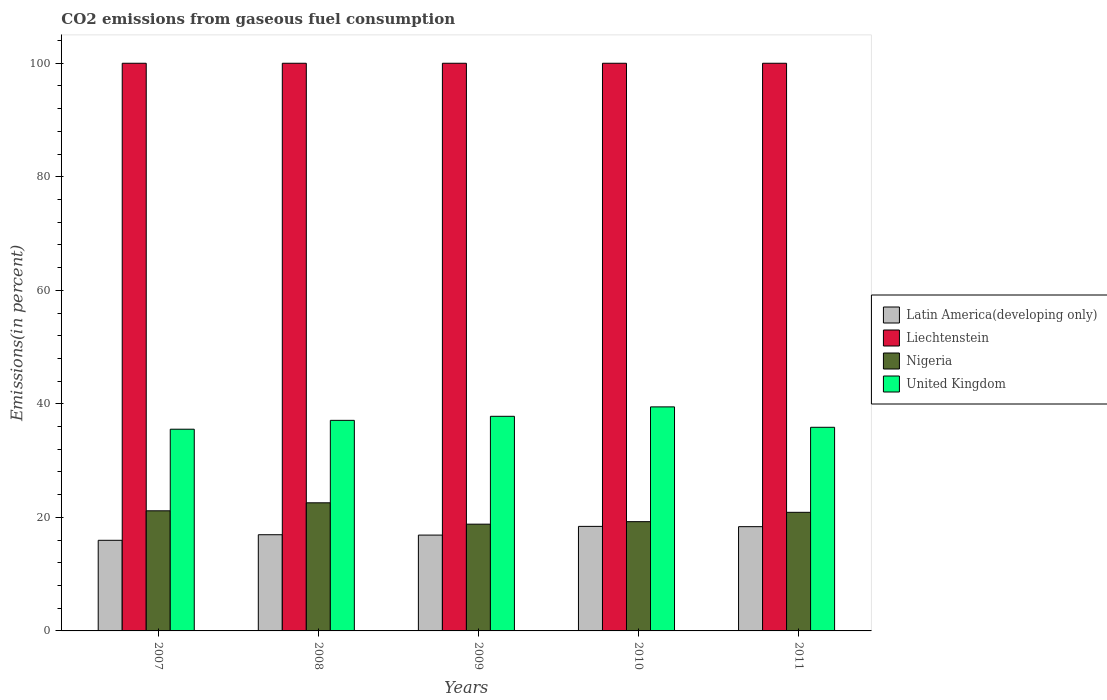Are the number of bars per tick equal to the number of legend labels?
Make the answer very short. Yes. How many bars are there on the 4th tick from the left?
Your answer should be very brief. 4. What is the label of the 3rd group of bars from the left?
Ensure brevity in your answer.  2009. In how many cases, is the number of bars for a given year not equal to the number of legend labels?
Your response must be concise. 0. Across all years, what is the maximum total CO2 emitted in Nigeria?
Ensure brevity in your answer.  22.57. Across all years, what is the minimum total CO2 emitted in Latin America(developing only)?
Your response must be concise. 15.96. In which year was the total CO2 emitted in United Kingdom minimum?
Your answer should be very brief. 2007. What is the total total CO2 emitted in Latin America(developing only) in the graph?
Provide a succinct answer. 86.57. What is the difference between the total CO2 emitted in Nigeria in 2007 and that in 2010?
Your response must be concise. 1.91. What is the difference between the total CO2 emitted in Latin America(developing only) in 2011 and the total CO2 emitted in Liechtenstein in 2009?
Keep it short and to the point. -81.64. What is the average total CO2 emitted in Latin America(developing only) per year?
Offer a terse response. 17.31. In the year 2008, what is the difference between the total CO2 emitted in Nigeria and total CO2 emitted in Latin America(developing only)?
Provide a short and direct response. 5.62. Is the difference between the total CO2 emitted in Nigeria in 2009 and 2011 greater than the difference between the total CO2 emitted in Latin America(developing only) in 2009 and 2011?
Give a very brief answer. No. What is the difference between the highest and the second highest total CO2 emitted in Latin America(developing only)?
Provide a short and direct response. 0.05. What is the difference between the highest and the lowest total CO2 emitted in Liechtenstein?
Keep it short and to the point. 0. In how many years, is the total CO2 emitted in United Kingdom greater than the average total CO2 emitted in United Kingdom taken over all years?
Ensure brevity in your answer.  2. Is the sum of the total CO2 emitted in United Kingdom in 2008 and 2011 greater than the maximum total CO2 emitted in Liechtenstein across all years?
Ensure brevity in your answer.  No. What does the 3rd bar from the left in 2009 represents?
Offer a very short reply. Nigeria. What does the 3rd bar from the right in 2011 represents?
Offer a very short reply. Liechtenstein. Is it the case that in every year, the sum of the total CO2 emitted in United Kingdom and total CO2 emitted in Nigeria is greater than the total CO2 emitted in Latin America(developing only)?
Your answer should be very brief. Yes. Are all the bars in the graph horizontal?
Offer a very short reply. No. Are the values on the major ticks of Y-axis written in scientific E-notation?
Your response must be concise. No. Does the graph contain grids?
Your response must be concise. No. How are the legend labels stacked?
Your response must be concise. Vertical. What is the title of the graph?
Your response must be concise. CO2 emissions from gaseous fuel consumption. What is the label or title of the Y-axis?
Keep it short and to the point. Emissions(in percent). What is the Emissions(in percent) in Latin America(developing only) in 2007?
Your answer should be very brief. 15.96. What is the Emissions(in percent) in Liechtenstein in 2007?
Make the answer very short. 100. What is the Emissions(in percent) in Nigeria in 2007?
Your answer should be compact. 21.16. What is the Emissions(in percent) of United Kingdom in 2007?
Keep it short and to the point. 35.53. What is the Emissions(in percent) of Latin America(developing only) in 2008?
Give a very brief answer. 16.94. What is the Emissions(in percent) of Nigeria in 2008?
Offer a very short reply. 22.57. What is the Emissions(in percent) of United Kingdom in 2008?
Your answer should be compact. 37.1. What is the Emissions(in percent) of Latin America(developing only) in 2009?
Ensure brevity in your answer.  16.88. What is the Emissions(in percent) of Nigeria in 2009?
Provide a short and direct response. 18.81. What is the Emissions(in percent) of United Kingdom in 2009?
Offer a very short reply. 37.81. What is the Emissions(in percent) of Latin America(developing only) in 2010?
Provide a short and direct response. 18.42. What is the Emissions(in percent) of Nigeria in 2010?
Your answer should be very brief. 19.25. What is the Emissions(in percent) of United Kingdom in 2010?
Your response must be concise. 39.47. What is the Emissions(in percent) in Latin America(developing only) in 2011?
Make the answer very short. 18.36. What is the Emissions(in percent) in Nigeria in 2011?
Offer a very short reply. 20.89. What is the Emissions(in percent) in United Kingdom in 2011?
Your answer should be very brief. 35.87. Across all years, what is the maximum Emissions(in percent) in Latin America(developing only)?
Your response must be concise. 18.42. Across all years, what is the maximum Emissions(in percent) in Liechtenstein?
Keep it short and to the point. 100. Across all years, what is the maximum Emissions(in percent) of Nigeria?
Your answer should be very brief. 22.57. Across all years, what is the maximum Emissions(in percent) in United Kingdom?
Give a very brief answer. 39.47. Across all years, what is the minimum Emissions(in percent) in Latin America(developing only)?
Ensure brevity in your answer.  15.96. Across all years, what is the minimum Emissions(in percent) in Liechtenstein?
Give a very brief answer. 100. Across all years, what is the minimum Emissions(in percent) of Nigeria?
Ensure brevity in your answer.  18.81. Across all years, what is the minimum Emissions(in percent) of United Kingdom?
Offer a terse response. 35.53. What is the total Emissions(in percent) of Latin America(developing only) in the graph?
Keep it short and to the point. 86.57. What is the total Emissions(in percent) of Nigeria in the graph?
Give a very brief answer. 102.67. What is the total Emissions(in percent) of United Kingdom in the graph?
Provide a short and direct response. 185.77. What is the difference between the Emissions(in percent) of Latin America(developing only) in 2007 and that in 2008?
Your answer should be very brief. -0.98. What is the difference between the Emissions(in percent) of Nigeria in 2007 and that in 2008?
Your answer should be compact. -1.41. What is the difference between the Emissions(in percent) in United Kingdom in 2007 and that in 2008?
Your answer should be very brief. -1.56. What is the difference between the Emissions(in percent) of Latin America(developing only) in 2007 and that in 2009?
Keep it short and to the point. -0.92. What is the difference between the Emissions(in percent) of Liechtenstein in 2007 and that in 2009?
Provide a short and direct response. 0. What is the difference between the Emissions(in percent) in Nigeria in 2007 and that in 2009?
Make the answer very short. 2.35. What is the difference between the Emissions(in percent) in United Kingdom in 2007 and that in 2009?
Provide a short and direct response. -2.28. What is the difference between the Emissions(in percent) in Latin America(developing only) in 2007 and that in 2010?
Offer a terse response. -2.45. What is the difference between the Emissions(in percent) in Nigeria in 2007 and that in 2010?
Ensure brevity in your answer.  1.91. What is the difference between the Emissions(in percent) of United Kingdom in 2007 and that in 2010?
Make the answer very short. -3.93. What is the difference between the Emissions(in percent) of Latin America(developing only) in 2007 and that in 2011?
Keep it short and to the point. -2.4. What is the difference between the Emissions(in percent) in Liechtenstein in 2007 and that in 2011?
Your response must be concise. 0. What is the difference between the Emissions(in percent) in Nigeria in 2007 and that in 2011?
Your answer should be very brief. 0.27. What is the difference between the Emissions(in percent) of United Kingdom in 2007 and that in 2011?
Make the answer very short. -0.34. What is the difference between the Emissions(in percent) of Latin America(developing only) in 2008 and that in 2009?
Ensure brevity in your answer.  0.06. What is the difference between the Emissions(in percent) in Liechtenstein in 2008 and that in 2009?
Your answer should be compact. 0. What is the difference between the Emissions(in percent) of Nigeria in 2008 and that in 2009?
Ensure brevity in your answer.  3.76. What is the difference between the Emissions(in percent) in United Kingdom in 2008 and that in 2009?
Give a very brief answer. -0.71. What is the difference between the Emissions(in percent) of Latin America(developing only) in 2008 and that in 2010?
Give a very brief answer. -1.47. What is the difference between the Emissions(in percent) of Liechtenstein in 2008 and that in 2010?
Your answer should be compact. 0. What is the difference between the Emissions(in percent) in Nigeria in 2008 and that in 2010?
Offer a terse response. 3.32. What is the difference between the Emissions(in percent) of United Kingdom in 2008 and that in 2010?
Provide a short and direct response. -2.37. What is the difference between the Emissions(in percent) of Latin America(developing only) in 2008 and that in 2011?
Ensure brevity in your answer.  -1.42. What is the difference between the Emissions(in percent) in Liechtenstein in 2008 and that in 2011?
Your answer should be compact. 0. What is the difference between the Emissions(in percent) of Nigeria in 2008 and that in 2011?
Your answer should be very brief. 1.68. What is the difference between the Emissions(in percent) in United Kingdom in 2008 and that in 2011?
Provide a short and direct response. 1.22. What is the difference between the Emissions(in percent) of Latin America(developing only) in 2009 and that in 2010?
Make the answer very short. -1.53. What is the difference between the Emissions(in percent) in Nigeria in 2009 and that in 2010?
Offer a very short reply. -0.44. What is the difference between the Emissions(in percent) in United Kingdom in 2009 and that in 2010?
Provide a short and direct response. -1.66. What is the difference between the Emissions(in percent) in Latin America(developing only) in 2009 and that in 2011?
Your response must be concise. -1.48. What is the difference between the Emissions(in percent) of Liechtenstein in 2009 and that in 2011?
Give a very brief answer. 0. What is the difference between the Emissions(in percent) of Nigeria in 2009 and that in 2011?
Make the answer very short. -2.08. What is the difference between the Emissions(in percent) of United Kingdom in 2009 and that in 2011?
Offer a terse response. 1.94. What is the difference between the Emissions(in percent) of Latin America(developing only) in 2010 and that in 2011?
Ensure brevity in your answer.  0.05. What is the difference between the Emissions(in percent) of Liechtenstein in 2010 and that in 2011?
Offer a very short reply. 0. What is the difference between the Emissions(in percent) of Nigeria in 2010 and that in 2011?
Your answer should be compact. -1.64. What is the difference between the Emissions(in percent) in United Kingdom in 2010 and that in 2011?
Your answer should be very brief. 3.6. What is the difference between the Emissions(in percent) of Latin America(developing only) in 2007 and the Emissions(in percent) of Liechtenstein in 2008?
Offer a very short reply. -84.04. What is the difference between the Emissions(in percent) in Latin America(developing only) in 2007 and the Emissions(in percent) in Nigeria in 2008?
Give a very brief answer. -6.6. What is the difference between the Emissions(in percent) in Latin America(developing only) in 2007 and the Emissions(in percent) in United Kingdom in 2008?
Make the answer very short. -21.13. What is the difference between the Emissions(in percent) of Liechtenstein in 2007 and the Emissions(in percent) of Nigeria in 2008?
Keep it short and to the point. 77.43. What is the difference between the Emissions(in percent) in Liechtenstein in 2007 and the Emissions(in percent) in United Kingdom in 2008?
Offer a terse response. 62.9. What is the difference between the Emissions(in percent) in Nigeria in 2007 and the Emissions(in percent) in United Kingdom in 2008?
Give a very brief answer. -15.94. What is the difference between the Emissions(in percent) of Latin America(developing only) in 2007 and the Emissions(in percent) of Liechtenstein in 2009?
Your answer should be very brief. -84.04. What is the difference between the Emissions(in percent) of Latin America(developing only) in 2007 and the Emissions(in percent) of Nigeria in 2009?
Give a very brief answer. -2.84. What is the difference between the Emissions(in percent) of Latin America(developing only) in 2007 and the Emissions(in percent) of United Kingdom in 2009?
Offer a terse response. -21.84. What is the difference between the Emissions(in percent) of Liechtenstein in 2007 and the Emissions(in percent) of Nigeria in 2009?
Make the answer very short. 81.19. What is the difference between the Emissions(in percent) of Liechtenstein in 2007 and the Emissions(in percent) of United Kingdom in 2009?
Your response must be concise. 62.19. What is the difference between the Emissions(in percent) in Nigeria in 2007 and the Emissions(in percent) in United Kingdom in 2009?
Offer a very short reply. -16.65. What is the difference between the Emissions(in percent) in Latin America(developing only) in 2007 and the Emissions(in percent) in Liechtenstein in 2010?
Offer a very short reply. -84.04. What is the difference between the Emissions(in percent) in Latin America(developing only) in 2007 and the Emissions(in percent) in Nigeria in 2010?
Keep it short and to the point. -3.28. What is the difference between the Emissions(in percent) in Latin America(developing only) in 2007 and the Emissions(in percent) in United Kingdom in 2010?
Offer a terse response. -23.5. What is the difference between the Emissions(in percent) of Liechtenstein in 2007 and the Emissions(in percent) of Nigeria in 2010?
Provide a succinct answer. 80.75. What is the difference between the Emissions(in percent) in Liechtenstein in 2007 and the Emissions(in percent) in United Kingdom in 2010?
Keep it short and to the point. 60.53. What is the difference between the Emissions(in percent) of Nigeria in 2007 and the Emissions(in percent) of United Kingdom in 2010?
Offer a very short reply. -18.31. What is the difference between the Emissions(in percent) of Latin America(developing only) in 2007 and the Emissions(in percent) of Liechtenstein in 2011?
Provide a succinct answer. -84.04. What is the difference between the Emissions(in percent) of Latin America(developing only) in 2007 and the Emissions(in percent) of Nigeria in 2011?
Give a very brief answer. -4.93. What is the difference between the Emissions(in percent) in Latin America(developing only) in 2007 and the Emissions(in percent) in United Kingdom in 2011?
Make the answer very short. -19.91. What is the difference between the Emissions(in percent) of Liechtenstein in 2007 and the Emissions(in percent) of Nigeria in 2011?
Offer a terse response. 79.11. What is the difference between the Emissions(in percent) in Liechtenstein in 2007 and the Emissions(in percent) in United Kingdom in 2011?
Your response must be concise. 64.13. What is the difference between the Emissions(in percent) in Nigeria in 2007 and the Emissions(in percent) in United Kingdom in 2011?
Your answer should be compact. -14.71. What is the difference between the Emissions(in percent) in Latin America(developing only) in 2008 and the Emissions(in percent) in Liechtenstein in 2009?
Provide a short and direct response. -83.06. What is the difference between the Emissions(in percent) of Latin America(developing only) in 2008 and the Emissions(in percent) of Nigeria in 2009?
Your answer should be very brief. -1.86. What is the difference between the Emissions(in percent) of Latin America(developing only) in 2008 and the Emissions(in percent) of United Kingdom in 2009?
Offer a terse response. -20.86. What is the difference between the Emissions(in percent) of Liechtenstein in 2008 and the Emissions(in percent) of Nigeria in 2009?
Your answer should be very brief. 81.19. What is the difference between the Emissions(in percent) of Liechtenstein in 2008 and the Emissions(in percent) of United Kingdom in 2009?
Make the answer very short. 62.19. What is the difference between the Emissions(in percent) of Nigeria in 2008 and the Emissions(in percent) of United Kingdom in 2009?
Make the answer very short. -15.24. What is the difference between the Emissions(in percent) of Latin America(developing only) in 2008 and the Emissions(in percent) of Liechtenstein in 2010?
Your answer should be very brief. -83.06. What is the difference between the Emissions(in percent) in Latin America(developing only) in 2008 and the Emissions(in percent) in Nigeria in 2010?
Keep it short and to the point. -2.3. What is the difference between the Emissions(in percent) of Latin America(developing only) in 2008 and the Emissions(in percent) of United Kingdom in 2010?
Provide a succinct answer. -22.52. What is the difference between the Emissions(in percent) in Liechtenstein in 2008 and the Emissions(in percent) in Nigeria in 2010?
Your response must be concise. 80.75. What is the difference between the Emissions(in percent) of Liechtenstein in 2008 and the Emissions(in percent) of United Kingdom in 2010?
Offer a very short reply. 60.53. What is the difference between the Emissions(in percent) in Nigeria in 2008 and the Emissions(in percent) in United Kingdom in 2010?
Give a very brief answer. -16.9. What is the difference between the Emissions(in percent) of Latin America(developing only) in 2008 and the Emissions(in percent) of Liechtenstein in 2011?
Your answer should be compact. -83.06. What is the difference between the Emissions(in percent) of Latin America(developing only) in 2008 and the Emissions(in percent) of Nigeria in 2011?
Your answer should be very brief. -3.95. What is the difference between the Emissions(in percent) in Latin America(developing only) in 2008 and the Emissions(in percent) in United Kingdom in 2011?
Your response must be concise. -18.93. What is the difference between the Emissions(in percent) in Liechtenstein in 2008 and the Emissions(in percent) in Nigeria in 2011?
Your answer should be compact. 79.11. What is the difference between the Emissions(in percent) of Liechtenstein in 2008 and the Emissions(in percent) of United Kingdom in 2011?
Give a very brief answer. 64.13. What is the difference between the Emissions(in percent) in Nigeria in 2008 and the Emissions(in percent) in United Kingdom in 2011?
Provide a short and direct response. -13.3. What is the difference between the Emissions(in percent) in Latin America(developing only) in 2009 and the Emissions(in percent) in Liechtenstein in 2010?
Keep it short and to the point. -83.12. What is the difference between the Emissions(in percent) in Latin America(developing only) in 2009 and the Emissions(in percent) in Nigeria in 2010?
Your answer should be very brief. -2.36. What is the difference between the Emissions(in percent) of Latin America(developing only) in 2009 and the Emissions(in percent) of United Kingdom in 2010?
Your answer should be very brief. -22.58. What is the difference between the Emissions(in percent) of Liechtenstein in 2009 and the Emissions(in percent) of Nigeria in 2010?
Give a very brief answer. 80.75. What is the difference between the Emissions(in percent) in Liechtenstein in 2009 and the Emissions(in percent) in United Kingdom in 2010?
Give a very brief answer. 60.53. What is the difference between the Emissions(in percent) of Nigeria in 2009 and the Emissions(in percent) of United Kingdom in 2010?
Provide a succinct answer. -20.66. What is the difference between the Emissions(in percent) of Latin America(developing only) in 2009 and the Emissions(in percent) of Liechtenstein in 2011?
Provide a short and direct response. -83.12. What is the difference between the Emissions(in percent) in Latin America(developing only) in 2009 and the Emissions(in percent) in Nigeria in 2011?
Offer a very short reply. -4.01. What is the difference between the Emissions(in percent) in Latin America(developing only) in 2009 and the Emissions(in percent) in United Kingdom in 2011?
Provide a succinct answer. -18.99. What is the difference between the Emissions(in percent) of Liechtenstein in 2009 and the Emissions(in percent) of Nigeria in 2011?
Ensure brevity in your answer.  79.11. What is the difference between the Emissions(in percent) in Liechtenstein in 2009 and the Emissions(in percent) in United Kingdom in 2011?
Keep it short and to the point. 64.13. What is the difference between the Emissions(in percent) of Nigeria in 2009 and the Emissions(in percent) of United Kingdom in 2011?
Provide a short and direct response. -17.06. What is the difference between the Emissions(in percent) of Latin America(developing only) in 2010 and the Emissions(in percent) of Liechtenstein in 2011?
Provide a succinct answer. -81.58. What is the difference between the Emissions(in percent) in Latin America(developing only) in 2010 and the Emissions(in percent) in Nigeria in 2011?
Keep it short and to the point. -2.48. What is the difference between the Emissions(in percent) in Latin America(developing only) in 2010 and the Emissions(in percent) in United Kingdom in 2011?
Your response must be concise. -17.46. What is the difference between the Emissions(in percent) in Liechtenstein in 2010 and the Emissions(in percent) in Nigeria in 2011?
Provide a short and direct response. 79.11. What is the difference between the Emissions(in percent) in Liechtenstein in 2010 and the Emissions(in percent) in United Kingdom in 2011?
Ensure brevity in your answer.  64.13. What is the difference between the Emissions(in percent) of Nigeria in 2010 and the Emissions(in percent) of United Kingdom in 2011?
Your answer should be very brief. -16.62. What is the average Emissions(in percent) in Latin America(developing only) per year?
Offer a very short reply. 17.31. What is the average Emissions(in percent) in Nigeria per year?
Keep it short and to the point. 20.53. What is the average Emissions(in percent) of United Kingdom per year?
Offer a terse response. 37.15. In the year 2007, what is the difference between the Emissions(in percent) of Latin America(developing only) and Emissions(in percent) of Liechtenstein?
Your answer should be very brief. -84.04. In the year 2007, what is the difference between the Emissions(in percent) of Latin America(developing only) and Emissions(in percent) of Nigeria?
Your answer should be very brief. -5.2. In the year 2007, what is the difference between the Emissions(in percent) in Latin America(developing only) and Emissions(in percent) in United Kingdom?
Provide a short and direct response. -19.57. In the year 2007, what is the difference between the Emissions(in percent) in Liechtenstein and Emissions(in percent) in Nigeria?
Keep it short and to the point. 78.84. In the year 2007, what is the difference between the Emissions(in percent) in Liechtenstein and Emissions(in percent) in United Kingdom?
Your answer should be compact. 64.47. In the year 2007, what is the difference between the Emissions(in percent) in Nigeria and Emissions(in percent) in United Kingdom?
Offer a very short reply. -14.37. In the year 2008, what is the difference between the Emissions(in percent) of Latin America(developing only) and Emissions(in percent) of Liechtenstein?
Provide a succinct answer. -83.06. In the year 2008, what is the difference between the Emissions(in percent) in Latin America(developing only) and Emissions(in percent) in Nigeria?
Offer a very short reply. -5.62. In the year 2008, what is the difference between the Emissions(in percent) in Latin America(developing only) and Emissions(in percent) in United Kingdom?
Offer a very short reply. -20.15. In the year 2008, what is the difference between the Emissions(in percent) in Liechtenstein and Emissions(in percent) in Nigeria?
Your answer should be compact. 77.43. In the year 2008, what is the difference between the Emissions(in percent) of Liechtenstein and Emissions(in percent) of United Kingdom?
Make the answer very short. 62.9. In the year 2008, what is the difference between the Emissions(in percent) in Nigeria and Emissions(in percent) in United Kingdom?
Provide a short and direct response. -14.53. In the year 2009, what is the difference between the Emissions(in percent) of Latin America(developing only) and Emissions(in percent) of Liechtenstein?
Make the answer very short. -83.12. In the year 2009, what is the difference between the Emissions(in percent) in Latin America(developing only) and Emissions(in percent) in Nigeria?
Offer a terse response. -1.93. In the year 2009, what is the difference between the Emissions(in percent) of Latin America(developing only) and Emissions(in percent) of United Kingdom?
Your answer should be very brief. -20.93. In the year 2009, what is the difference between the Emissions(in percent) of Liechtenstein and Emissions(in percent) of Nigeria?
Give a very brief answer. 81.19. In the year 2009, what is the difference between the Emissions(in percent) of Liechtenstein and Emissions(in percent) of United Kingdom?
Give a very brief answer. 62.19. In the year 2009, what is the difference between the Emissions(in percent) of Nigeria and Emissions(in percent) of United Kingdom?
Offer a terse response. -19. In the year 2010, what is the difference between the Emissions(in percent) in Latin America(developing only) and Emissions(in percent) in Liechtenstein?
Offer a very short reply. -81.58. In the year 2010, what is the difference between the Emissions(in percent) of Latin America(developing only) and Emissions(in percent) of Nigeria?
Your answer should be very brief. -0.83. In the year 2010, what is the difference between the Emissions(in percent) of Latin America(developing only) and Emissions(in percent) of United Kingdom?
Make the answer very short. -21.05. In the year 2010, what is the difference between the Emissions(in percent) in Liechtenstein and Emissions(in percent) in Nigeria?
Ensure brevity in your answer.  80.75. In the year 2010, what is the difference between the Emissions(in percent) of Liechtenstein and Emissions(in percent) of United Kingdom?
Ensure brevity in your answer.  60.53. In the year 2010, what is the difference between the Emissions(in percent) of Nigeria and Emissions(in percent) of United Kingdom?
Your answer should be compact. -20.22. In the year 2011, what is the difference between the Emissions(in percent) of Latin America(developing only) and Emissions(in percent) of Liechtenstein?
Ensure brevity in your answer.  -81.64. In the year 2011, what is the difference between the Emissions(in percent) of Latin America(developing only) and Emissions(in percent) of Nigeria?
Offer a very short reply. -2.53. In the year 2011, what is the difference between the Emissions(in percent) of Latin America(developing only) and Emissions(in percent) of United Kingdom?
Offer a very short reply. -17.51. In the year 2011, what is the difference between the Emissions(in percent) in Liechtenstein and Emissions(in percent) in Nigeria?
Your answer should be very brief. 79.11. In the year 2011, what is the difference between the Emissions(in percent) in Liechtenstein and Emissions(in percent) in United Kingdom?
Give a very brief answer. 64.13. In the year 2011, what is the difference between the Emissions(in percent) in Nigeria and Emissions(in percent) in United Kingdom?
Provide a short and direct response. -14.98. What is the ratio of the Emissions(in percent) of Latin America(developing only) in 2007 to that in 2008?
Provide a succinct answer. 0.94. What is the ratio of the Emissions(in percent) in Liechtenstein in 2007 to that in 2008?
Ensure brevity in your answer.  1. What is the ratio of the Emissions(in percent) of Nigeria in 2007 to that in 2008?
Offer a terse response. 0.94. What is the ratio of the Emissions(in percent) in United Kingdom in 2007 to that in 2008?
Make the answer very short. 0.96. What is the ratio of the Emissions(in percent) in Latin America(developing only) in 2007 to that in 2009?
Offer a very short reply. 0.95. What is the ratio of the Emissions(in percent) in Liechtenstein in 2007 to that in 2009?
Provide a succinct answer. 1. What is the ratio of the Emissions(in percent) of Nigeria in 2007 to that in 2009?
Keep it short and to the point. 1.12. What is the ratio of the Emissions(in percent) in United Kingdom in 2007 to that in 2009?
Your answer should be compact. 0.94. What is the ratio of the Emissions(in percent) in Latin America(developing only) in 2007 to that in 2010?
Your answer should be compact. 0.87. What is the ratio of the Emissions(in percent) in Nigeria in 2007 to that in 2010?
Make the answer very short. 1.1. What is the ratio of the Emissions(in percent) of United Kingdom in 2007 to that in 2010?
Provide a succinct answer. 0.9. What is the ratio of the Emissions(in percent) in Latin America(developing only) in 2007 to that in 2011?
Offer a terse response. 0.87. What is the ratio of the Emissions(in percent) of Nigeria in 2007 to that in 2011?
Your response must be concise. 1.01. What is the ratio of the Emissions(in percent) of United Kingdom in 2007 to that in 2011?
Offer a very short reply. 0.99. What is the ratio of the Emissions(in percent) in Latin America(developing only) in 2008 to that in 2009?
Make the answer very short. 1. What is the ratio of the Emissions(in percent) in Nigeria in 2008 to that in 2009?
Give a very brief answer. 1.2. What is the ratio of the Emissions(in percent) in United Kingdom in 2008 to that in 2009?
Ensure brevity in your answer.  0.98. What is the ratio of the Emissions(in percent) in Latin America(developing only) in 2008 to that in 2010?
Offer a terse response. 0.92. What is the ratio of the Emissions(in percent) in Liechtenstein in 2008 to that in 2010?
Your response must be concise. 1. What is the ratio of the Emissions(in percent) of Nigeria in 2008 to that in 2010?
Your answer should be compact. 1.17. What is the ratio of the Emissions(in percent) in United Kingdom in 2008 to that in 2010?
Ensure brevity in your answer.  0.94. What is the ratio of the Emissions(in percent) of Latin America(developing only) in 2008 to that in 2011?
Keep it short and to the point. 0.92. What is the ratio of the Emissions(in percent) in Nigeria in 2008 to that in 2011?
Ensure brevity in your answer.  1.08. What is the ratio of the Emissions(in percent) in United Kingdom in 2008 to that in 2011?
Make the answer very short. 1.03. What is the ratio of the Emissions(in percent) of Latin America(developing only) in 2009 to that in 2010?
Offer a terse response. 0.92. What is the ratio of the Emissions(in percent) of Liechtenstein in 2009 to that in 2010?
Provide a short and direct response. 1. What is the ratio of the Emissions(in percent) of Nigeria in 2009 to that in 2010?
Your answer should be compact. 0.98. What is the ratio of the Emissions(in percent) in United Kingdom in 2009 to that in 2010?
Make the answer very short. 0.96. What is the ratio of the Emissions(in percent) of Latin America(developing only) in 2009 to that in 2011?
Ensure brevity in your answer.  0.92. What is the ratio of the Emissions(in percent) in Liechtenstein in 2009 to that in 2011?
Provide a short and direct response. 1. What is the ratio of the Emissions(in percent) in Nigeria in 2009 to that in 2011?
Provide a succinct answer. 0.9. What is the ratio of the Emissions(in percent) of United Kingdom in 2009 to that in 2011?
Offer a terse response. 1.05. What is the ratio of the Emissions(in percent) in Latin America(developing only) in 2010 to that in 2011?
Offer a very short reply. 1. What is the ratio of the Emissions(in percent) of Nigeria in 2010 to that in 2011?
Your response must be concise. 0.92. What is the ratio of the Emissions(in percent) in United Kingdom in 2010 to that in 2011?
Offer a terse response. 1.1. What is the difference between the highest and the second highest Emissions(in percent) in Latin America(developing only)?
Give a very brief answer. 0.05. What is the difference between the highest and the second highest Emissions(in percent) of Liechtenstein?
Your answer should be compact. 0. What is the difference between the highest and the second highest Emissions(in percent) in Nigeria?
Make the answer very short. 1.41. What is the difference between the highest and the second highest Emissions(in percent) in United Kingdom?
Provide a short and direct response. 1.66. What is the difference between the highest and the lowest Emissions(in percent) of Latin America(developing only)?
Your answer should be compact. 2.45. What is the difference between the highest and the lowest Emissions(in percent) of Liechtenstein?
Provide a short and direct response. 0. What is the difference between the highest and the lowest Emissions(in percent) of Nigeria?
Your answer should be compact. 3.76. What is the difference between the highest and the lowest Emissions(in percent) of United Kingdom?
Offer a very short reply. 3.93. 